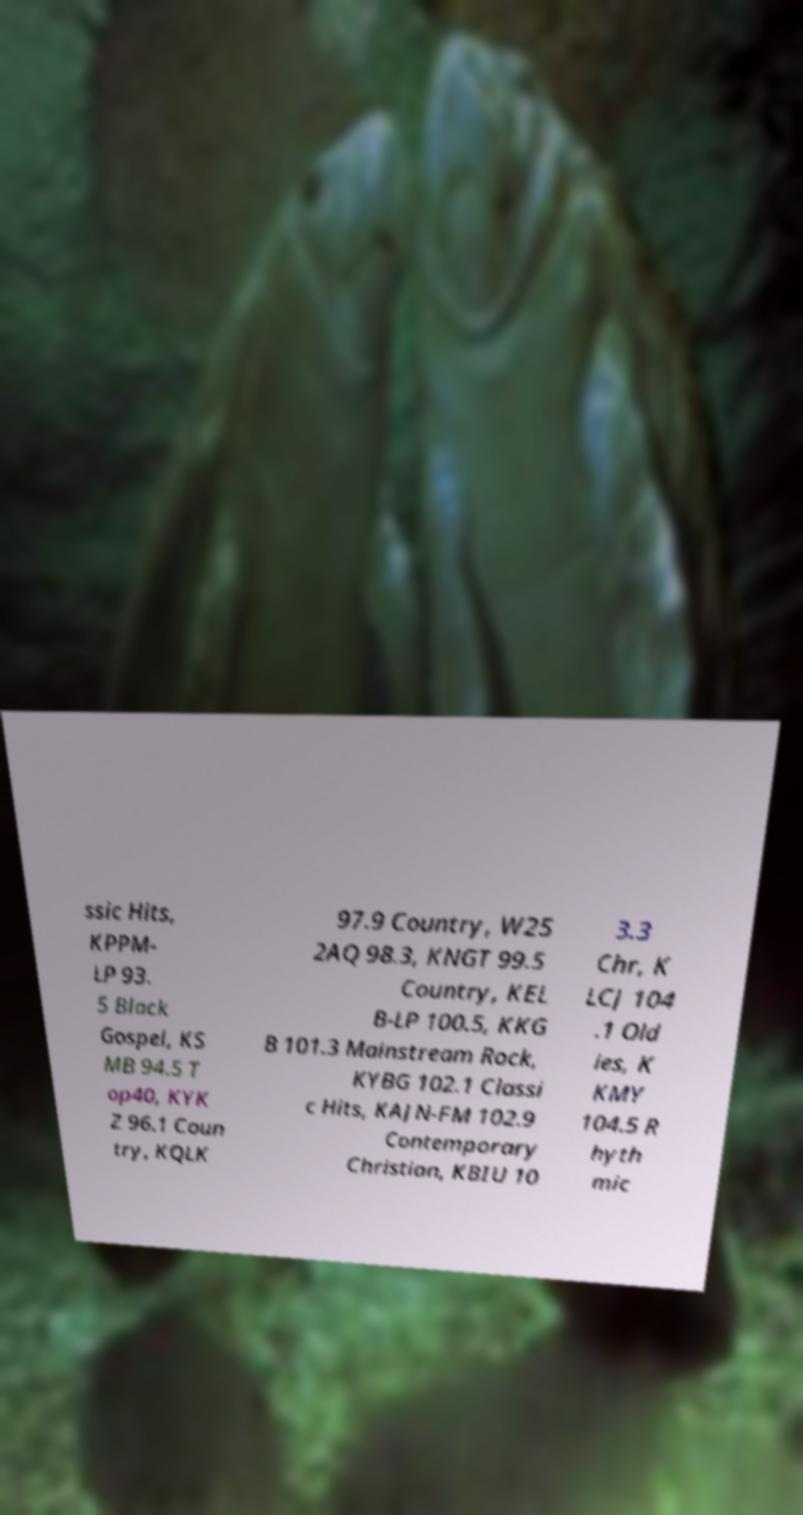Can you accurately transcribe the text from the provided image for me? ssic Hits, KPPM- LP 93. 5 Black Gospel, KS MB 94.5 T op40, KYK Z 96.1 Coun try, KQLK 97.9 Country, W25 2AQ 98.3, KNGT 99.5 Country, KEL B-LP 100.5, KKG B 101.3 Mainstream Rock, KYBG 102.1 Classi c Hits, KAJN-FM 102.9 Contemporary Christian, KBIU 10 3.3 Chr, K LCJ 104 .1 Old ies, K KMY 104.5 R hyth mic 